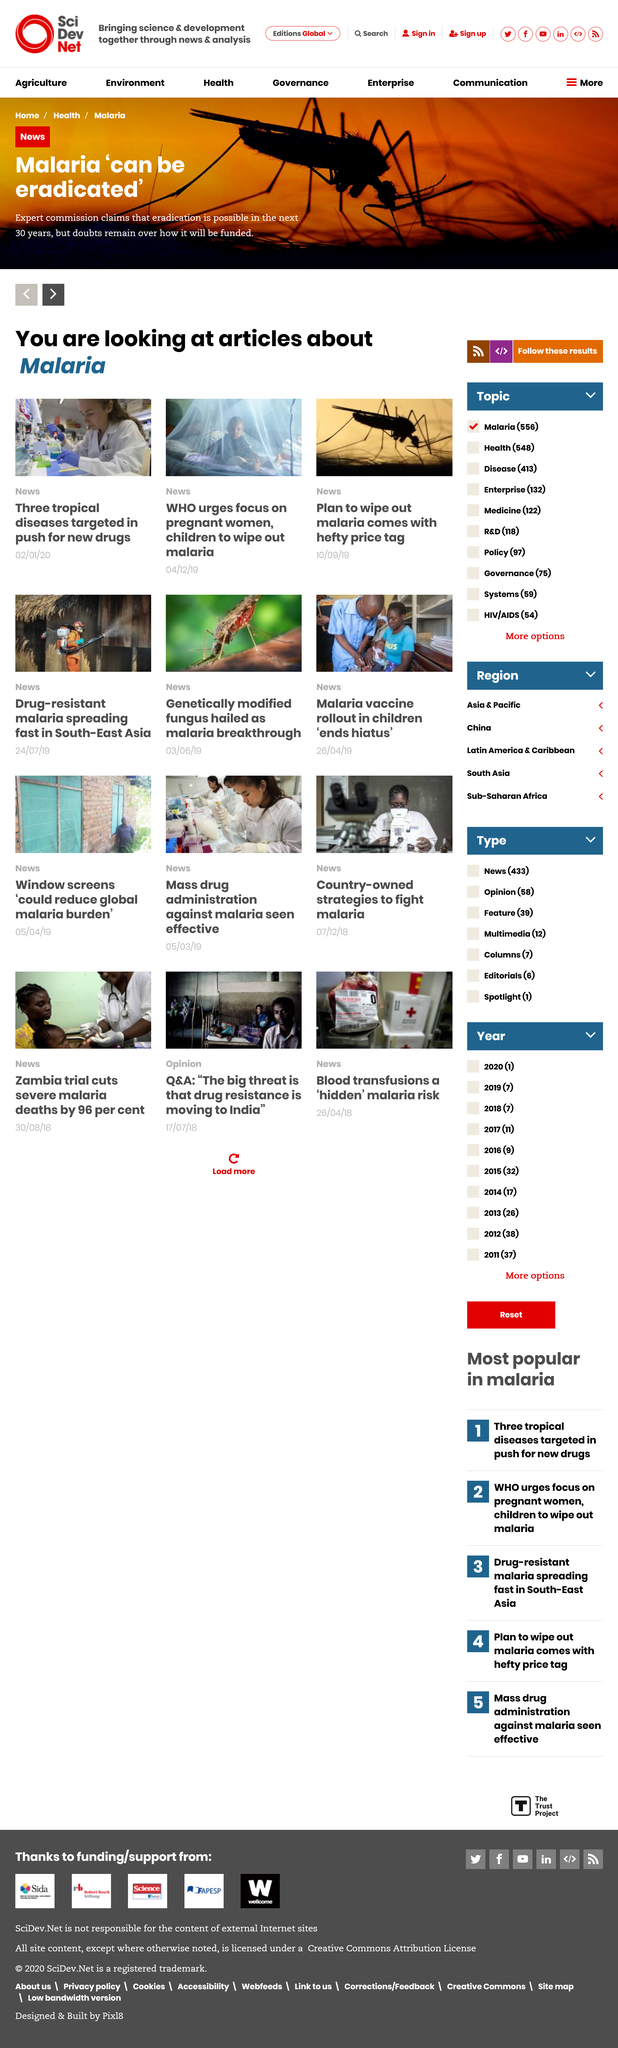List a handful of essential elements in this visual. The topic of these articles is malaria. The article "Three tropical diseases targeted in push for new drugs" was published on 02/01/2023. Malaria may be eradicated within the next 30 years, according to experts. 